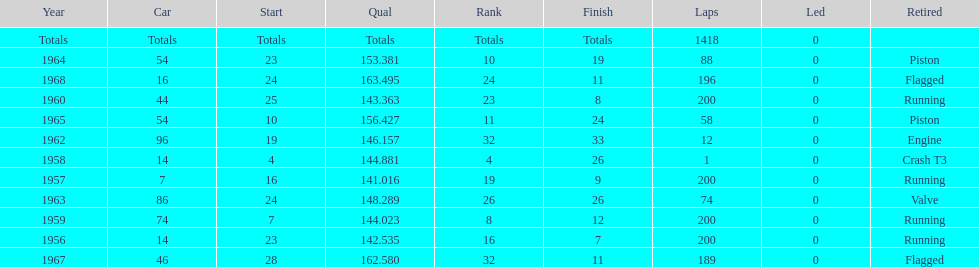Did bob veith drive more indy 500 laps in the 1950s or 1960s? 1960s. 